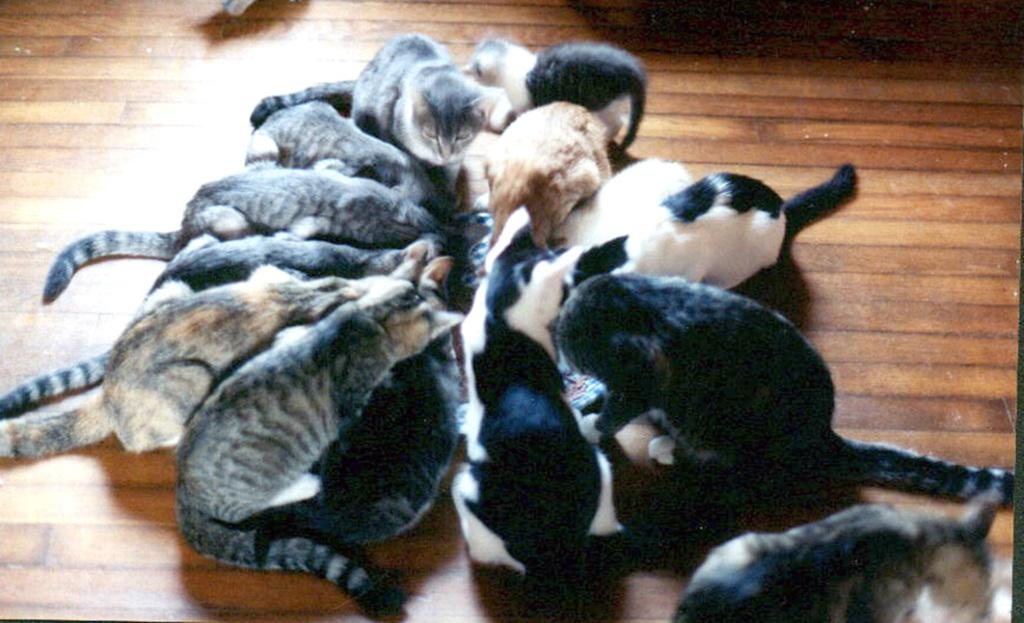What type of animals can be seen in the image? There are many cats in the image. What is the surface that the cats are on? The cats are on a wooden floor. Is there any quicksand visible in the image? No, there is no quicksand present in the image. What type of sign can be seen in the image? There is no sign visible in the image. 